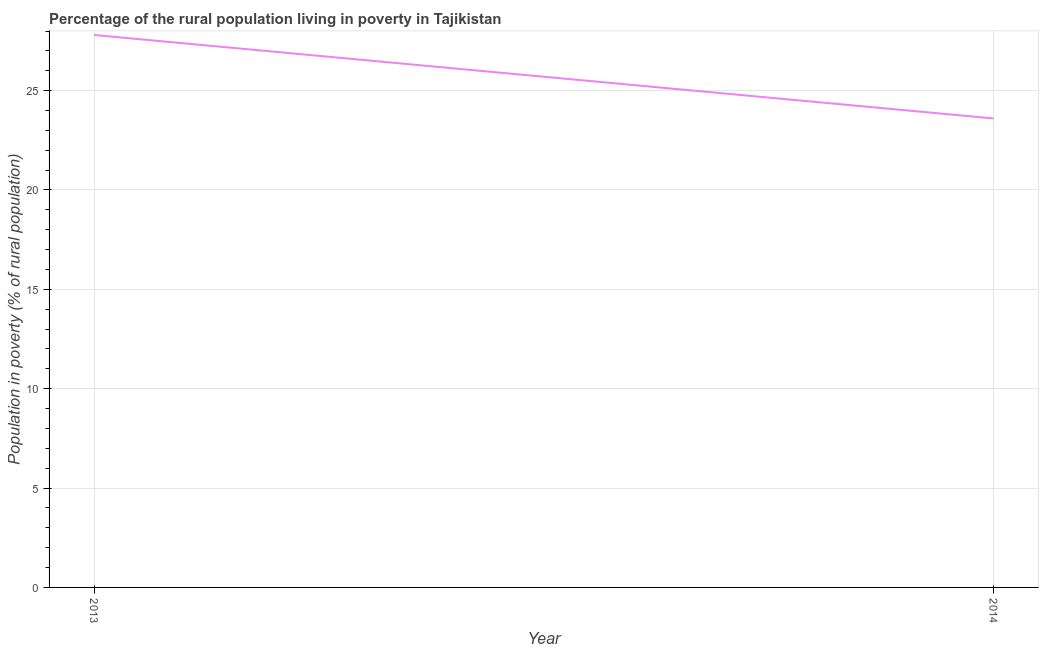What is the percentage of rural population living below poverty line in 2013?
Your answer should be very brief. 27.8. Across all years, what is the maximum percentage of rural population living below poverty line?
Offer a very short reply. 27.8. Across all years, what is the minimum percentage of rural population living below poverty line?
Make the answer very short. 23.6. What is the sum of the percentage of rural population living below poverty line?
Provide a short and direct response. 51.4. What is the difference between the percentage of rural population living below poverty line in 2013 and 2014?
Ensure brevity in your answer.  4.2. What is the average percentage of rural population living below poverty line per year?
Offer a terse response. 25.7. What is the median percentage of rural population living below poverty line?
Provide a succinct answer. 25.7. What is the ratio of the percentage of rural population living below poverty line in 2013 to that in 2014?
Offer a terse response. 1.18. Does the percentage of rural population living below poverty line monotonically increase over the years?
Offer a very short reply. No. How many years are there in the graph?
Your answer should be very brief. 2. Does the graph contain any zero values?
Offer a very short reply. No. What is the title of the graph?
Offer a very short reply. Percentage of the rural population living in poverty in Tajikistan. What is the label or title of the X-axis?
Your response must be concise. Year. What is the label or title of the Y-axis?
Provide a succinct answer. Population in poverty (% of rural population). What is the Population in poverty (% of rural population) in 2013?
Keep it short and to the point. 27.8. What is the Population in poverty (% of rural population) in 2014?
Ensure brevity in your answer.  23.6. What is the difference between the Population in poverty (% of rural population) in 2013 and 2014?
Make the answer very short. 4.2. What is the ratio of the Population in poverty (% of rural population) in 2013 to that in 2014?
Your answer should be compact. 1.18. 